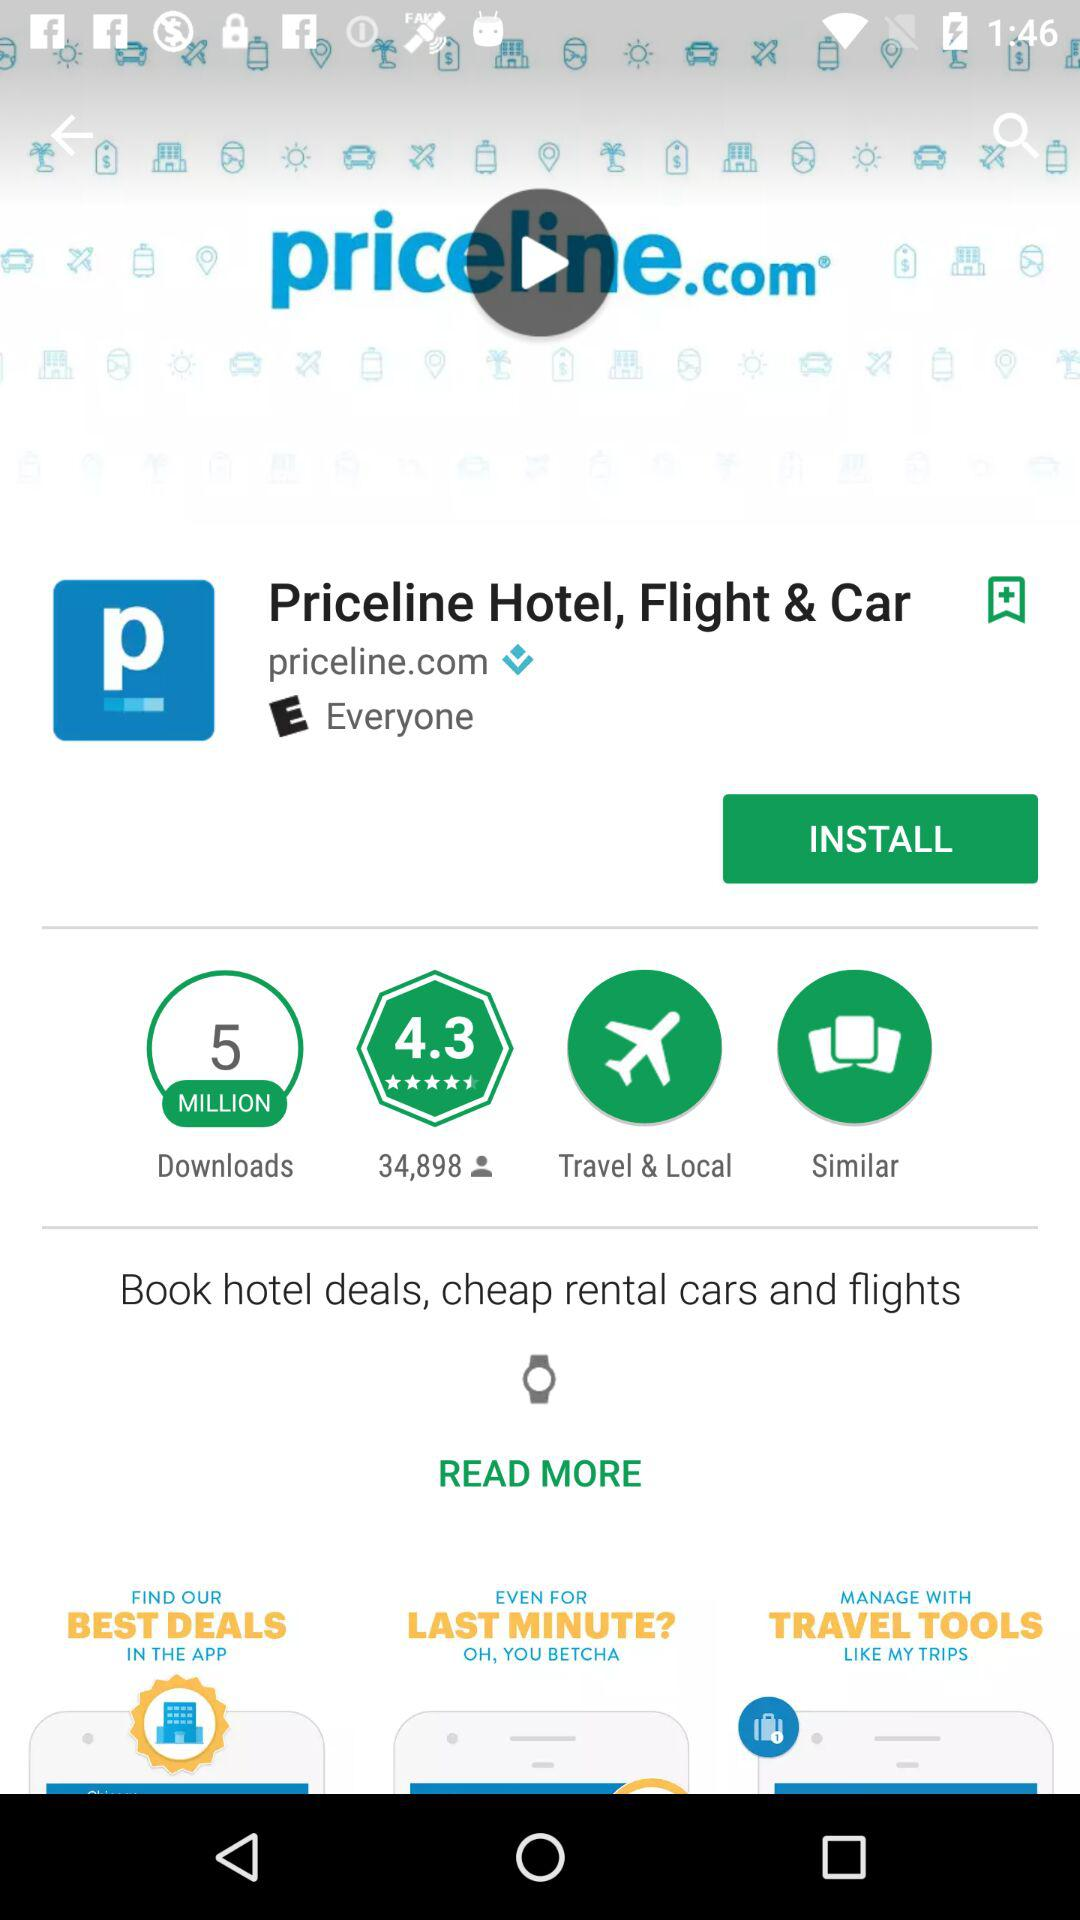How many million downloads are there? There are 5 million downloads. 